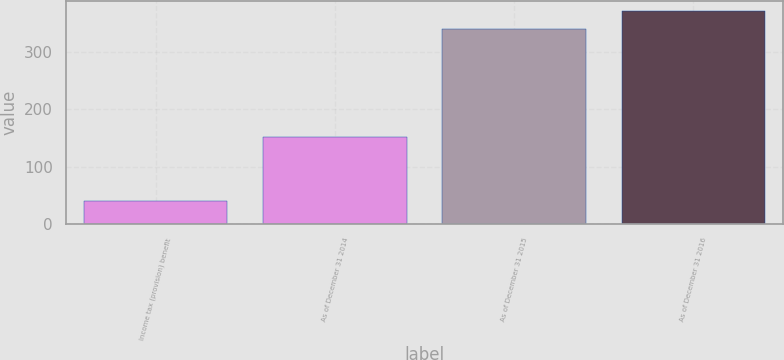Convert chart. <chart><loc_0><loc_0><loc_500><loc_500><bar_chart><fcel>Income tax (provision) benefit<fcel>As of December 31 2014<fcel>As of December 31 2015<fcel>As of December 31 2016<nl><fcel>40<fcel>151<fcel>339<fcel>370<nl></chart> 